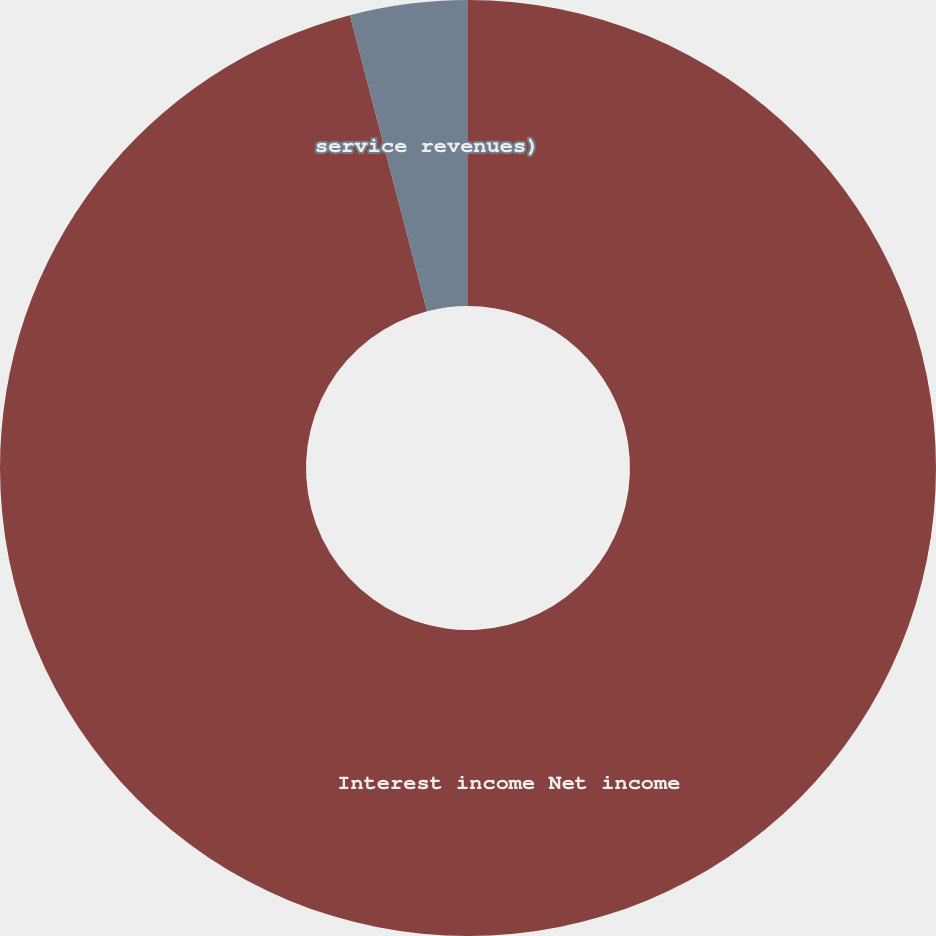Convert chart to OTSL. <chart><loc_0><loc_0><loc_500><loc_500><pie_chart><fcel>Interest income Net income<fcel>service revenues)<nl><fcel>95.94%<fcel>4.06%<nl></chart> 